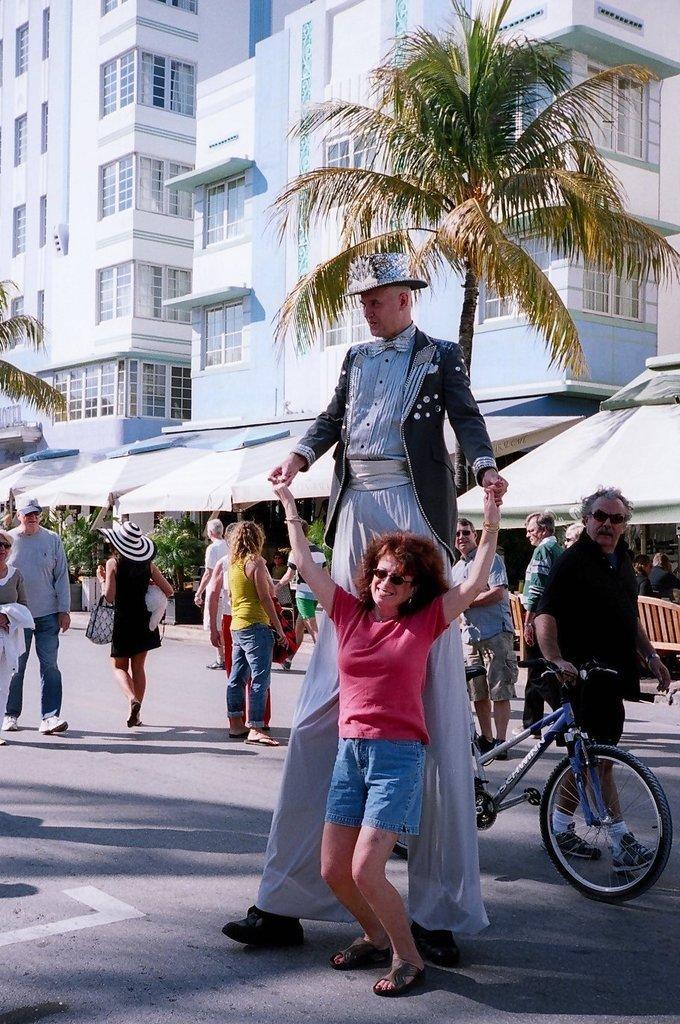Please provide a concise description of this image. In this picture there are people in the center of the image and there are buildings and trees in the background area of the image, there are stalls in the center of the image. 